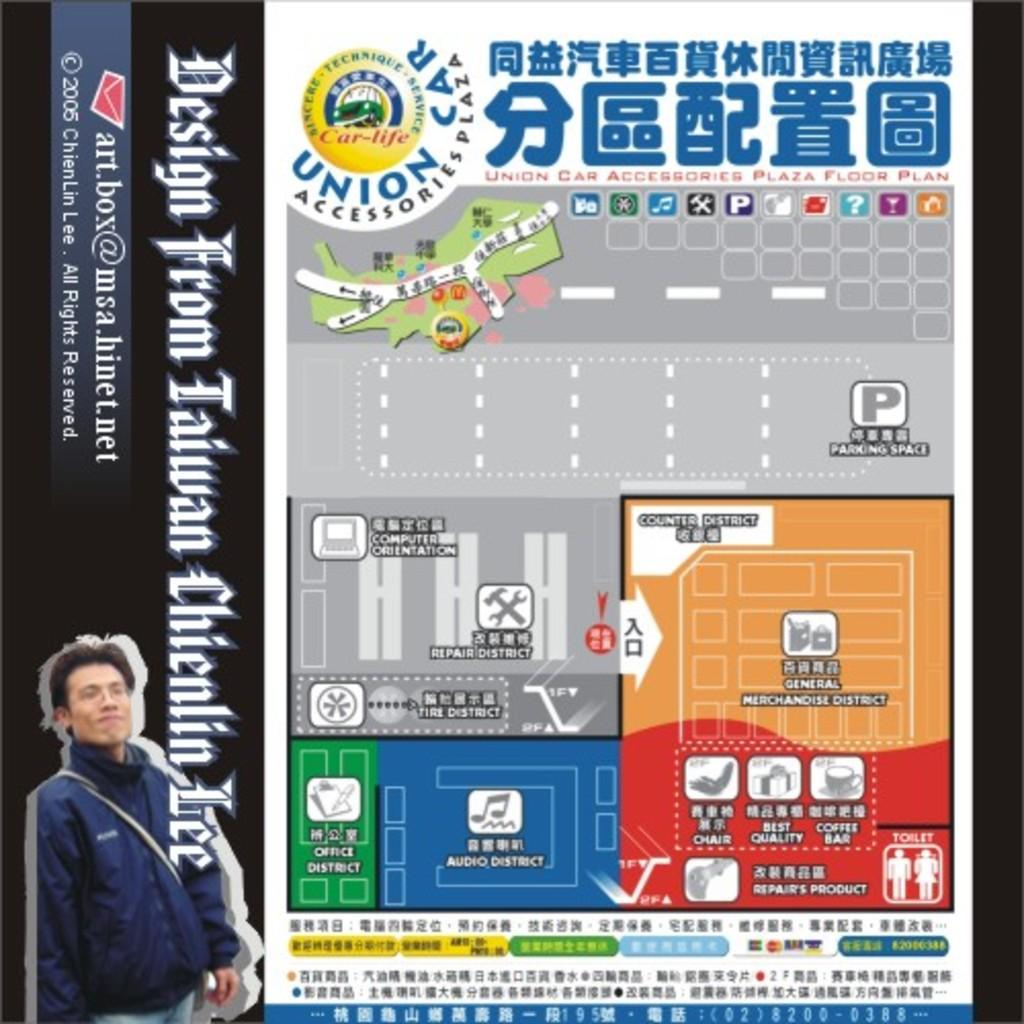<image>
Describe the image concisely. an ad for something with a guy on it standing next to the name Lee 